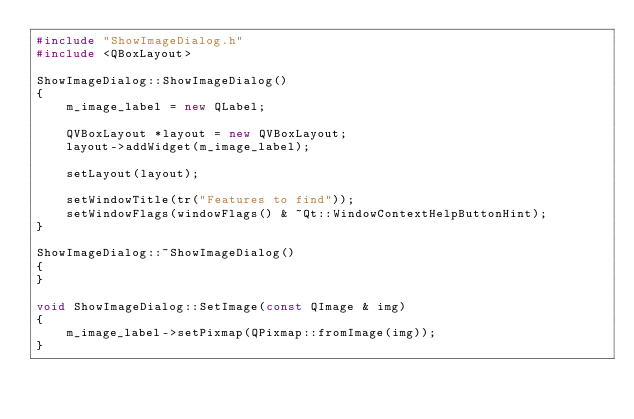<code> <loc_0><loc_0><loc_500><loc_500><_C++_>#include "ShowImageDialog.h"
#include <QBoxLayout>

ShowImageDialog::ShowImageDialog()
{
	m_image_label = new QLabel;

	QVBoxLayout *layout = new QVBoxLayout;
	layout->addWidget(m_image_label);

	setLayout(layout);

	setWindowTitle(tr("Features to find"));
	setWindowFlags(windowFlags() & ~Qt::WindowContextHelpButtonHint);
}

ShowImageDialog::~ShowImageDialog()
{
}

void ShowImageDialog::SetImage(const QImage & img)
{
	m_image_label->setPixmap(QPixmap::fromImage(img));
}
</code> 